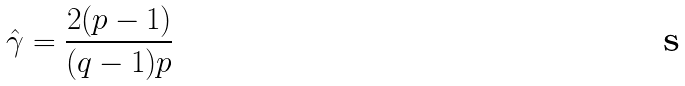Convert formula to latex. <formula><loc_0><loc_0><loc_500><loc_500>\hat { \gamma } = \frac { 2 ( p - 1 ) } { ( q - 1 ) p }</formula> 